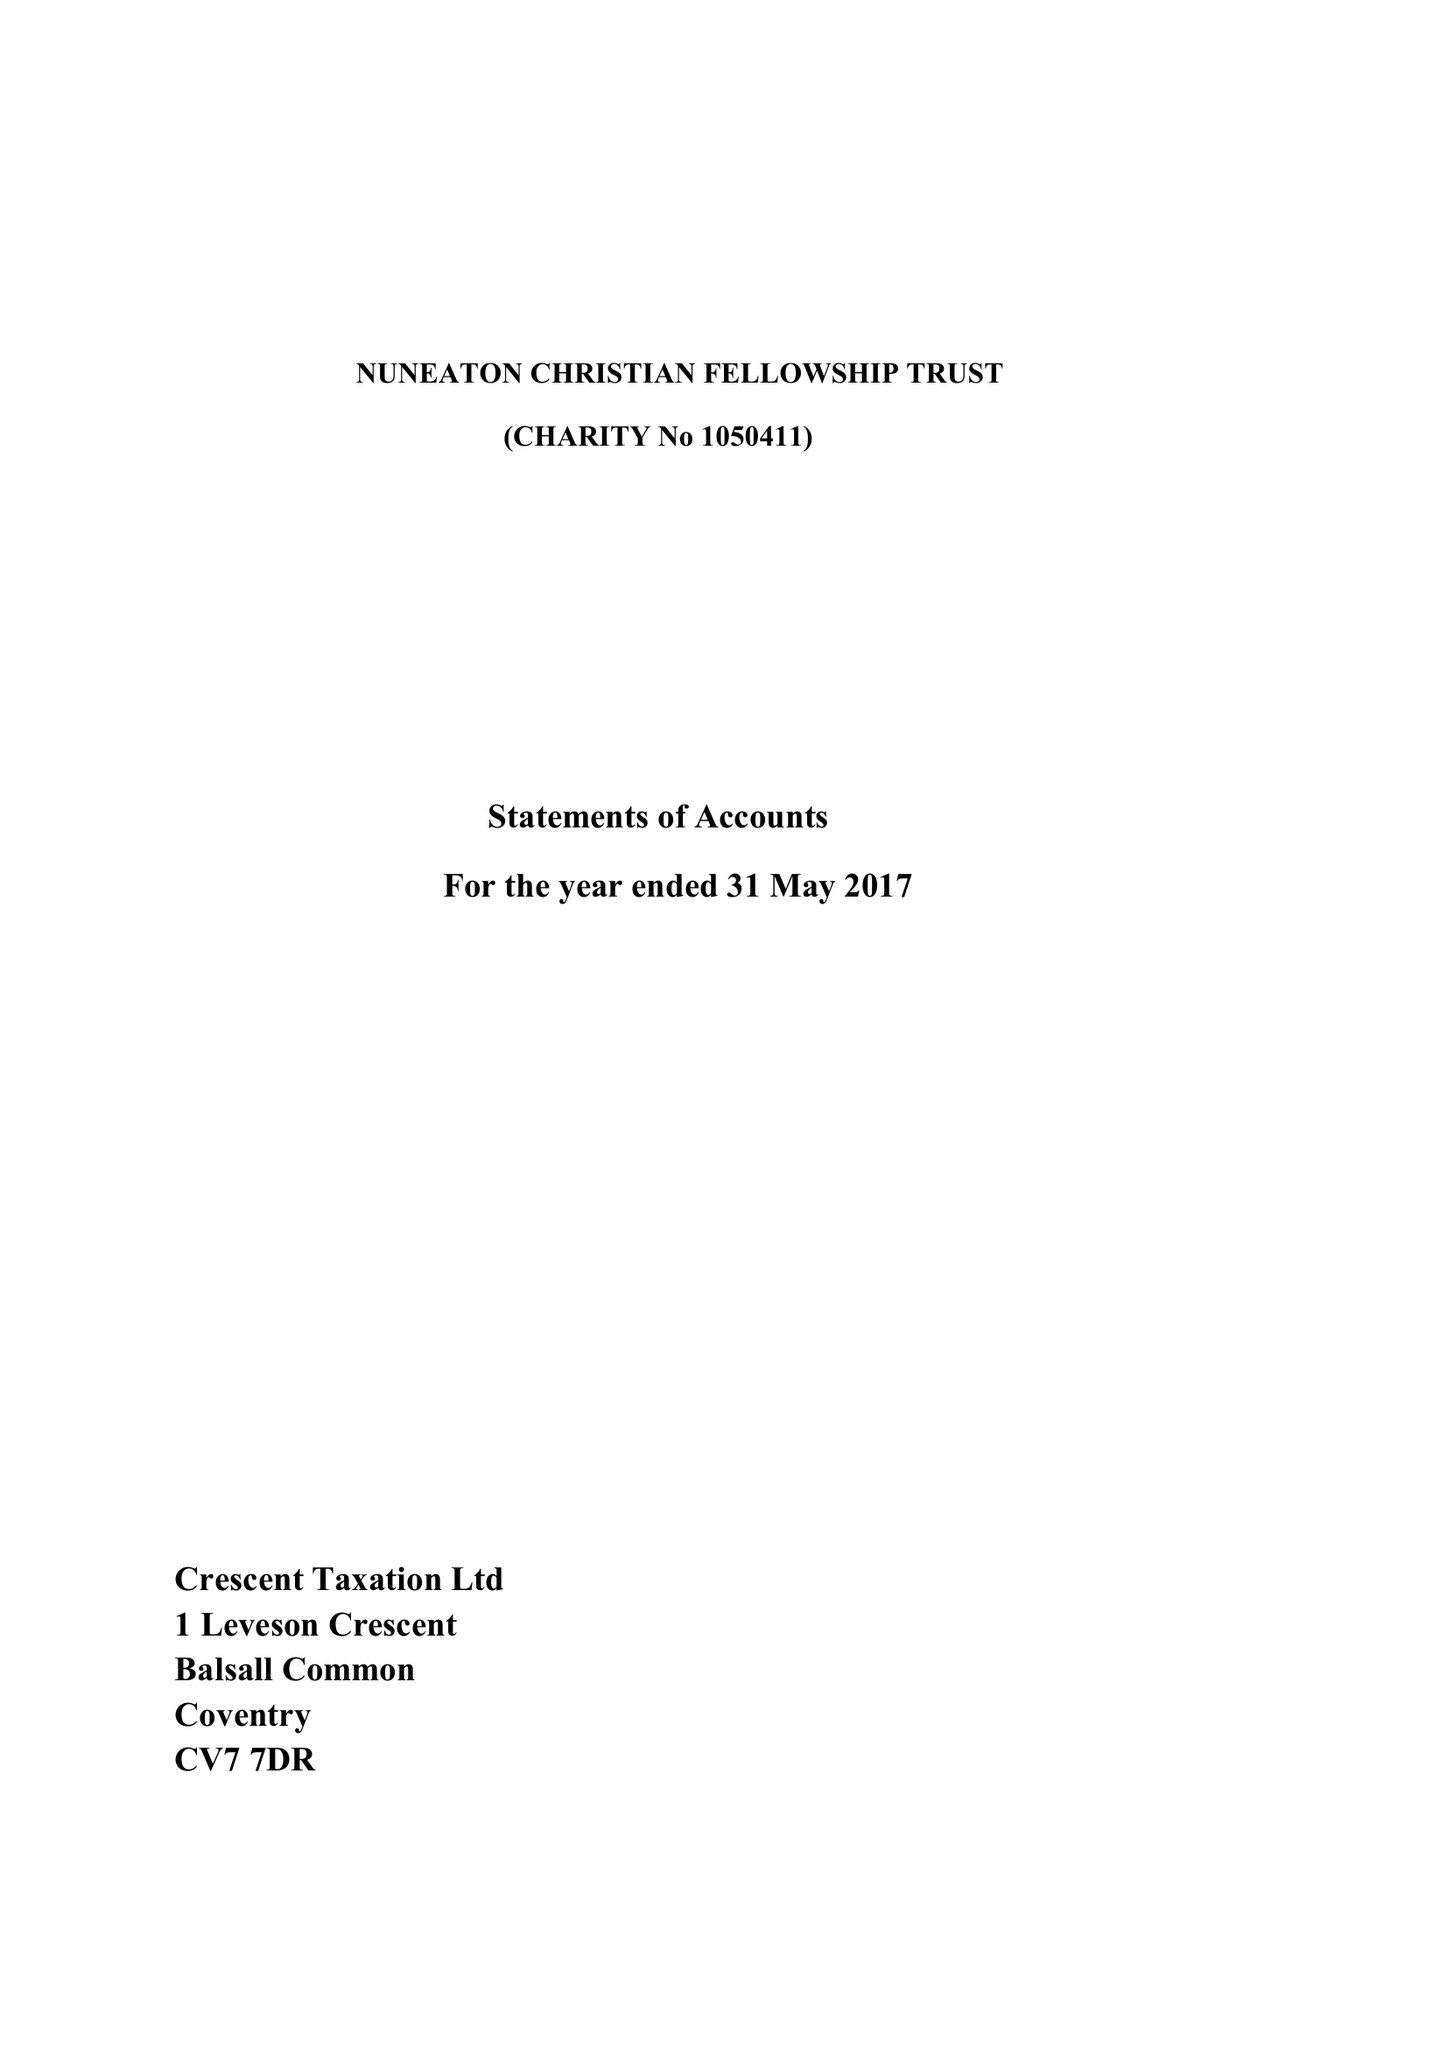What is the value for the report_date?
Answer the question using a single word or phrase. 2017-05-31 